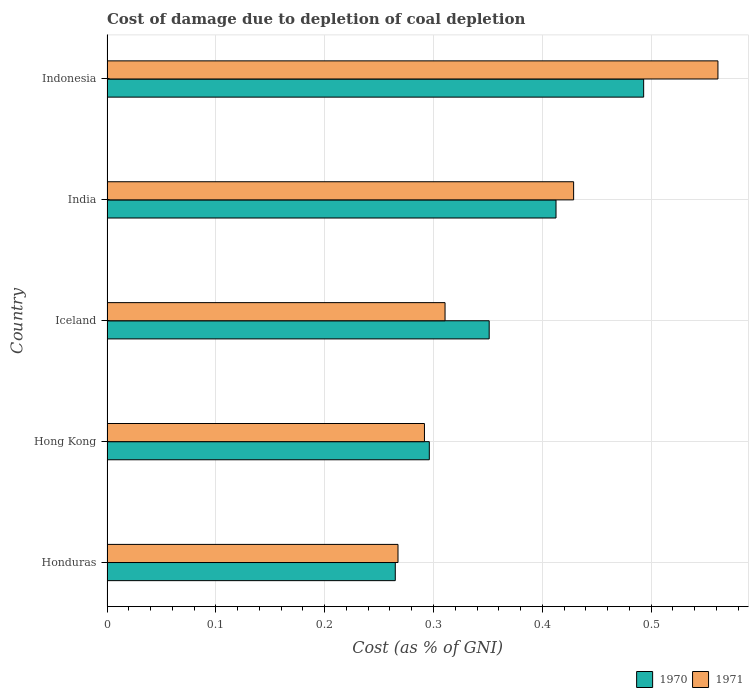How many different coloured bars are there?
Provide a short and direct response. 2. How many groups of bars are there?
Provide a short and direct response. 5. Are the number of bars on each tick of the Y-axis equal?
Keep it short and to the point. Yes. How many bars are there on the 5th tick from the bottom?
Keep it short and to the point. 2. What is the cost of damage caused due to coal depletion in 1971 in India?
Provide a short and direct response. 0.43. Across all countries, what is the maximum cost of damage caused due to coal depletion in 1970?
Your response must be concise. 0.49. Across all countries, what is the minimum cost of damage caused due to coal depletion in 1971?
Provide a short and direct response. 0.27. In which country was the cost of damage caused due to coal depletion in 1970 maximum?
Provide a short and direct response. Indonesia. In which country was the cost of damage caused due to coal depletion in 1970 minimum?
Offer a very short reply. Honduras. What is the total cost of damage caused due to coal depletion in 1971 in the graph?
Provide a short and direct response. 1.86. What is the difference between the cost of damage caused due to coal depletion in 1971 in Iceland and that in Indonesia?
Offer a terse response. -0.25. What is the difference between the cost of damage caused due to coal depletion in 1970 in Hong Kong and the cost of damage caused due to coal depletion in 1971 in India?
Keep it short and to the point. -0.13. What is the average cost of damage caused due to coal depletion in 1970 per country?
Offer a very short reply. 0.36. What is the difference between the cost of damage caused due to coal depletion in 1970 and cost of damage caused due to coal depletion in 1971 in Iceland?
Ensure brevity in your answer.  0.04. What is the ratio of the cost of damage caused due to coal depletion in 1971 in Honduras to that in Hong Kong?
Offer a very short reply. 0.92. Is the difference between the cost of damage caused due to coal depletion in 1970 in Iceland and India greater than the difference between the cost of damage caused due to coal depletion in 1971 in Iceland and India?
Your response must be concise. Yes. What is the difference between the highest and the second highest cost of damage caused due to coal depletion in 1971?
Provide a short and direct response. 0.13. What is the difference between the highest and the lowest cost of damage caused due to coal depletion in 1970?
Keep it short and to the point. 0.23. In how many countries, is the cost of damage caused due to coal depletion in 1970 greater than the average cost of damage caused due to coal depletion in 1970 taken over all countries?
Your response must be concise. 2. What does the 1st bar from the top in Honduras represents?
Keep it short and to the point. 1971. What does the 2nd bar from the bottom in Honduras represents?
Make the answer very short. 1971. How many bars are there?
Provide a succinct answer. 10. Are all the bars in the graph horizontal?
Provide a succinct answer. Yes. Does the graph contain any zero values?
Your answer should be very brief. No. Where does the legend appear in the graph?
Your answer should be compact. Bottom right. How many legend labels are there?
Your answer should be compact. 2. What is the title of the graph?
Your answer should be very brief. Cost of damage due to depletion of coal depletion. What is the label or title of the X-axis?
Give a very brief answer. Cost (as % of GNI). What is the Cost (as % of GNI) in 1970 in Honduras?
Give a very brief answer. 0.26. What is the Cost (as % of GNI) of 1971 in Honduras?
Make the answer very short. 0.27. What is the Cost (as % of GNI) of 1970 in Hong Kong?
Provide a succinct answer. 0.3. What is the Cost (as % of GNI) of 1971 in Hong Kong?
Keep it short and to the point. 0.29. What is the Cost (as % of GNI) in 1970 in Iceland?
Your answer should be very brief. 0.35. What is the Cost (as % of GNI) in 1971 in Iceland?
Your answer should be very brief. 0.31. What is the Cost (as % of GNI) in 1970 in India?
Keep it short and to the point. 0.41. What is the Cost (as % of GNI) in 1971 in India?
Your answer should be very brief. 0.43. What is the Cost (as % of GNI) in 1970 in Indonesia?
Your response must be concise. 0.49. What is the Cost (as % of GNI) of 1971 in Indonesia?
Keep it short and to the point. 0.56. Across all countries, what is the maximum Cost (as % of GNI) of 1970?
Keep it short and to the point. 0.49. Across all countries, what is the maximum Cost (as % of GNI) in 1971?
Offer a very short reply. 0.56. Across all countries, what is the minimum Cost (as % of GNI) of 1970?
Offer a very short reply. 0.26. Across all countries, what is the minimum Cost (as % of GNI) of 1971?
Your answer should be compact. 0.27. What is the total Cost (as % of GNI) in 1970 in the graph?
Offer a terse response. 1.82. What is the total Cost (as % of GNI) in 1971 in the graph?
Ensure brevity in your answer.  1.86. What is the difference between the Cost (as % of GNI) of 1970 in Honduras and that in Hong Kong?
Give a very brief answer. -0.03. What is the difference between the Cost (as % of GNI) of 1971 in Honduras and that in Hong Kong?
Provide a short and direct response. -0.02. What is the difference between the Cost (as % of GNI) in 1970 in Honduras and that in Iceland?
Provide a short and direct response. -0.09. What is the difference between the Cost (as % of GNI) in 1971 in Honduras and that in Iceland?
Offer a very short reply. -0.04. What is the difference between the Cost (as % of GNI) of 1970 in Honduras and that in India?
Your answer should be very brief. -0.15. What is the difference between the Cost (as % of GNI) of 1971 in Honduras and that in India?
Your response must be concise. -0.16. What is the difference between the Cost (as % of GNI) of 1970 in Honduras and that in Indonesia?
Your response must be concise. -0.23. What is the difference between the Cost (as % of GNI) of 1971 in Honduras and that in Indonesia?
Your answer should be compact. -0.29. What is the difference between the Cost (as % of GNI) in 1970 in Hong Kong and that in Iceland?
Make the answer very short. -0.06. What is the difference between the Cost (as % of GNI) in 1971 in Hong Kong and that in Iceland?
Your answer should be very brief. -0.02. What is the difference between the Cost (as % of GNI) of 1970 in Hong Kong and that in India?
Provide a succinct answer. -0.12. What is the difference between the Cost (as % of GNI) of 1971 in Hong Kong and that in India?
Ensure brevity in your answer.  -0.14. What is the difference between the Cost (as % of GNI) in 1970 in Hong Kong and that in Indonesia?
Your answer should be compact. -0.2. What is the difference between the Cost (as % of GNI) of 1971 in Hong Kong and that in Indonesia?
Your response must be concise. -0.27. What is the difference between the Cost (as % of GNI) in 1970 in Iceland and that in India?
Offer a terse response. -0.06. What is the difference between the Cost (as % of GNI) in 1971 in Iceland and that in India?
Ensure brevity in your answer.  -0.12. What is the difference between the Cost (as % of GNI) of 1970 in Iceland and that in Indonesia?
Offer a terse response. -0.14. What is the difference between the Cost (as % of GNI) of 1971 in Iceland and that in Indonesia?
Give a very brief answer. -0.25. What is the difference between the Cost (as % of GNI) in 1970 in India and that in Indonesia?
Your answer should be compact. -0.08. What is the difference between the Cost (as % of GNI) of 1971 in India and that in Indonesia?
Offer a very short reply. -0.13. What is the difference between the Cost (as % of GNI) of 1970 in Honduras and the Cost (as % of GNI) of 1971 in Hong Kong?
Offer a very short reply. -0.03. What is the difference between the Cost (as % of GNI) of 1970 in Honduras and the Cost (as % of GNI) of 1971 in Iceland?
Your answer should be compact. -0.05. What is the difference between the Cost (as % of GNI) in 1970 in Honduras and the Cost (as % of GNI) in 1971 in India?
Offer a terse response. -0.16. What is the difference between the Cost (as % of GNI) of 1970 in Honduras and the Cost (as % of GNI) of 1971 in Indonesia?
Provide a short and direct response. -0.3. What is the difference between the Cost (as % of GNI) in 1970 in Hong Kong and the Cost (as % of GNI) in 1971 in Iceland?
Your response must be concise. -0.01. What is the difference between the Cost (as % of GNI) in 1970 in Hong Kong and the Cost (as % of GNI) in 1971 in India?
Make the answer very short. -0.13. What is the difference between the Cost (as % of GNI) of 1970 in Hong Kong and the Cost (as % of GNI) of 1971 in Indonesia?
Your answer should be compact. -0.27. What is the difference between the Cost (as % of GNI) of 1970 in Iceland and the Cost (as % of GNI) of 1971 in India?
Offer a very short reply. -0.08. What is the difference between the Cost (as % of GNI) in 1970 in Iceland and the Cost (as % of GNI) in 1971 in Indonesia?
Provide a succinct answer. -0.21. What is the difference between the Cost (as % of GNI) of 1970 in India and the Cost (as % of GNI) of 1971 in Indonesia?
Offer a terse response. -0.15. What is the average Cost (as % of GNI) in 1970 per country?
Ensure brevity in your answer.  0.36. What is the average Cost (as % of GNI) of 1971 per country?
Offer a very short reply. 0.37. What is the difference between the Cost (as % of GNI) in 1970 and Cost (as % of GNI) in 1971 in Honduras?
Provide a short and direct response. -0. What is the difference between the Cost (as % of GNI) of 1970 and Cost (as % of GNI) of 1971 in Hong Kong?
Your answer should be very brief. 0. What is the difference between the Cost (as % of GNI) in 1970 and Cost (as % of GNI) in 1971 in Iceland?
Your answer should be very brief. 0.04. What is the difference between the Cost (as % of GNI) of 1970 and Cost (as % of GNI) of 1971 in India?
Your answer should be very brief. -0.02. What is the difference between the Cost (as % of GNI) of 1970 and Cost (as % of GNI) of 1971 in Indonesia?
Offer a terse response. -0.07. What is the ratio of the Cost (as % of GNI) of 1970 in Honduras to that in Hong Kong?
Offer a very short reply. 0.89. What is the ratio of the Cost (as % of GNI) in 1970 in Honduras to that in Iceland?
Your answer should be very brief. 0.75. What is the ratio of the Cost (as % of GNI) in 1971 in Honduras to that in Iceland?
Give a very brief answer. 0.86. What is the ratio of the Cost (as % of GNI) in 1970 in Honduras to that in India?
Provide a short and direct response. 0.64. What is the ratio of the Cost (as % of GNI) of 1971 in Honduras to that in India?
Provide a succinct answer. 0.62. What is the ratio of the Cost (as % of GNI) in 1970 in Honduras to that in Indonesia?
Provide a succinct answer. 0.54. What is the ratio of the Cost (as % of GNI) in 1971 in Honduras to that in Indonesia?
Your answer should be compact. 0.48. What is the ratio of the Cost (as % of GNI) in 1970 in Hong Kong to that in Iceland?
Make the answer very short. 0.84. What is the ratio of the Cost (as % of GNI) in 1971 in Hong Kong to that in Iceland?
Your response must be concise. 0.94. What is the ratio of the Cost (as % of GNI) of 1970 in Hong Kong to that in India?
Your answer should be compact. 0.72. What is the ratio of the Cost (as % of GNI) in 1971 in Hong Kong to that in India?
Provide a succinct answer. 0.68. What is the ratio of the Cost (as % of GNI) in 1970 in Hong Kong to that in Indonesia?
Give a very brief answer. 0.6. What is the ratio of the Cost (as % of GNI) of 1971 in Hong Kong to that in Indonesia?
Ensure brevity in your answer.  0.52. What is the ratio of the Cost (as % of GNI) of 1970 in Iceland to that in India?
Keep it short and to the point. 0.85. What is the ratio of the Cost (as % of GNI) in 1971 in Iceland to that in India?
Your answer should be compact. 0.72. What is the ratio of the Cost (as % of GNI) in 1970 in Iceland to that in Indonesia?
Your answer should be compact. 0.71. What is the ratio of the Cost (as % of GNI) of 1971 in Iceland to that in Indonesia?
Provide a short and direct response. 0.55. What is the ratio of the Cost (as % of GNI) in 1970 in India to that in Indonesia?
Give a very brief answer. 0.84. What is the ratio of the Cost (as % of GNI) of 1971 in India to that in Indonesia?
Make the answer very short. 0.76. What is the difference between the highest and the second highest Cost (as % of GNI) in 1970?
Give a very brief answer. 0.08. What is the difference between the highest and the second highest Cost (as % of GNI) of 1971?
Provide a succinct answer. 0.13. What is the difference between the highest and the lowest Cost (as % of GNI) in 1970?
Make the answer very short. 0.23. What is the difference between the highest and the lowest Cost (as % of GNI) of 1971?
Your response must be concise. 0.29. 